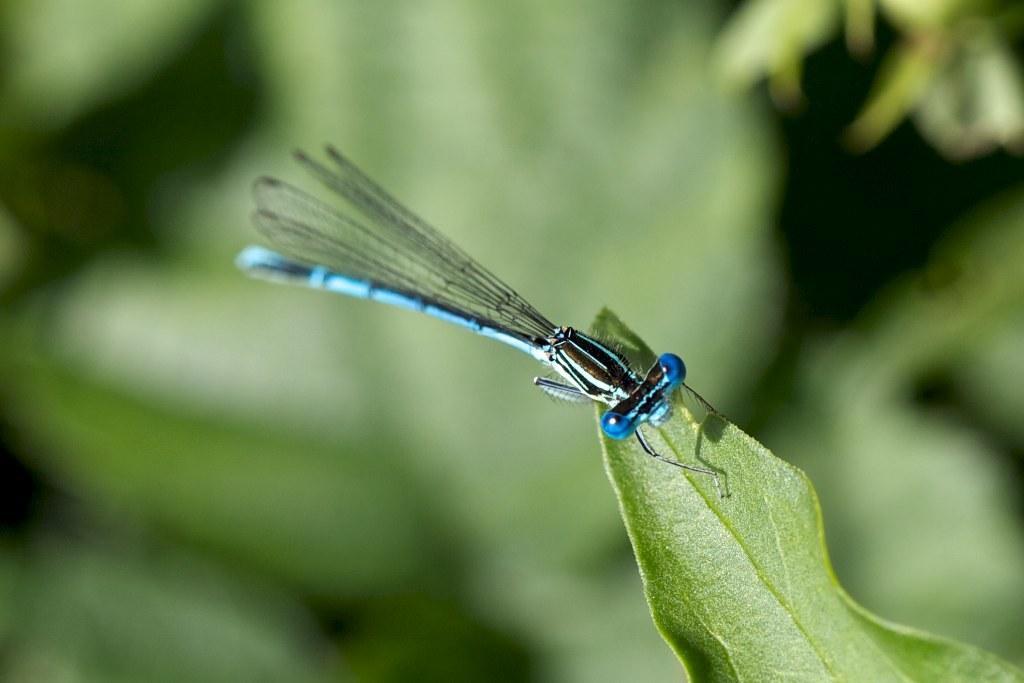Can you describe this image briefly? In this picture we can see an insect on a leaf and in the background it is blurry. 